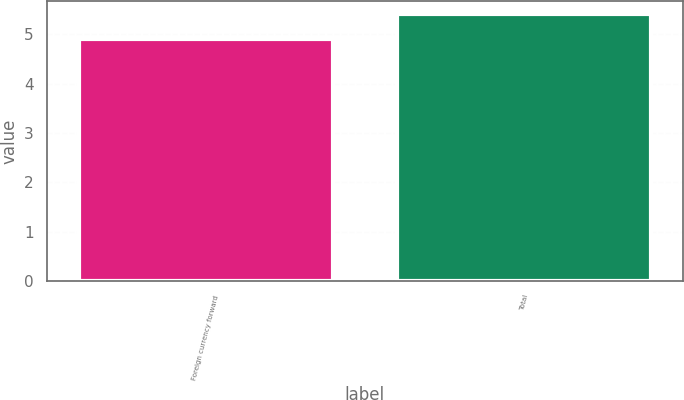<chart> <loc_0><loc_0><loc_500><loc_500><bar_chart><fcel>Foreign currency forward<fcel>Total<nl><fcel>4.9<fcel>5.4<nl></chart> 